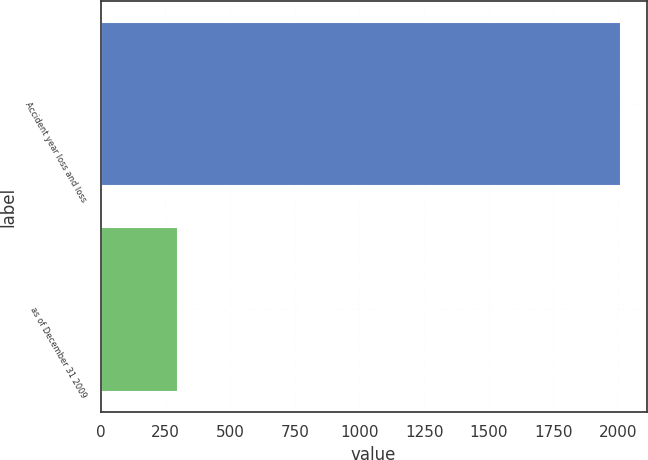Convert chart to OTSL. <chart><loc_0><loc_0><loc_500><loc_500><bar_chart><fcel>Accident year loss and loss<fcel>as of December 31 2009<nl><fcel>2009<fcel>298<nl></chart> 